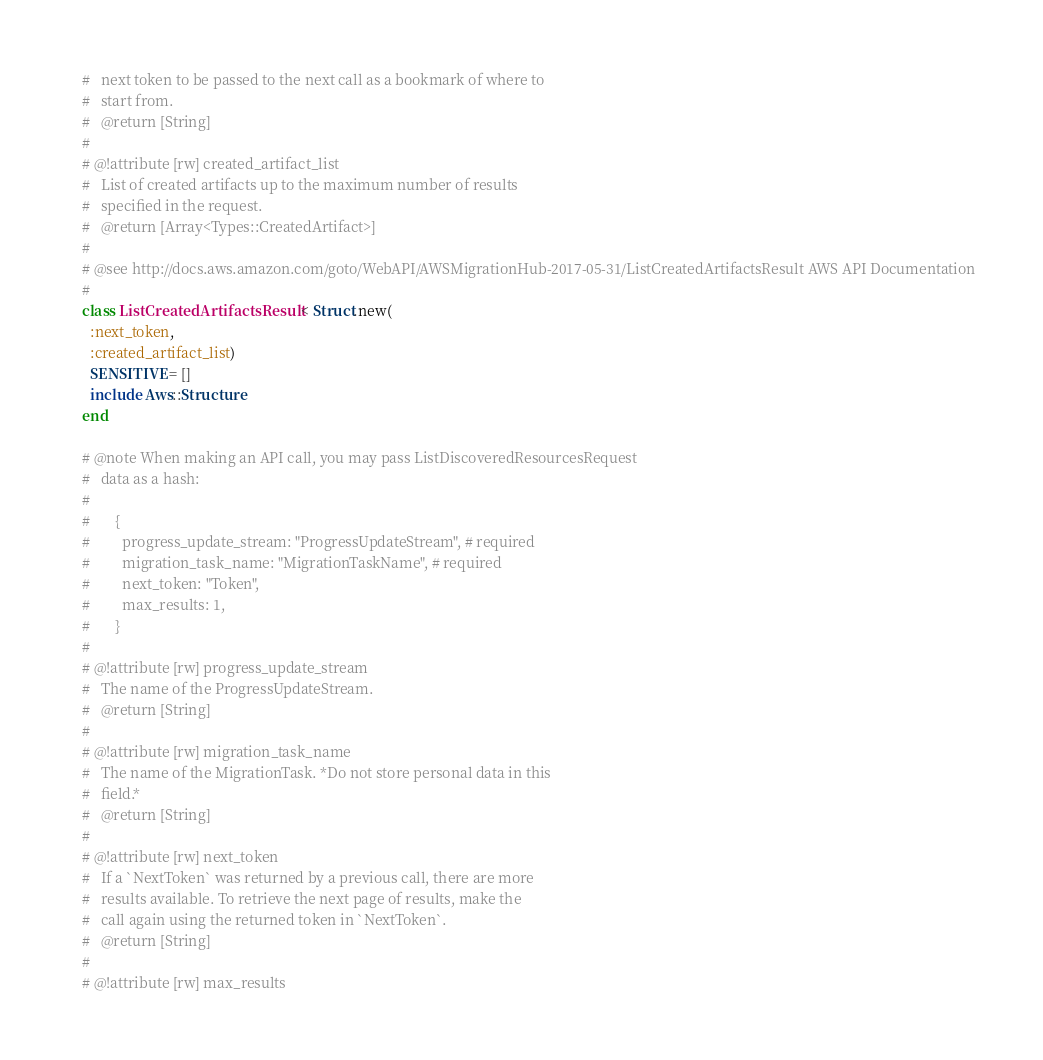Convert code to text. <code><loc_0><loc_0><loc_500><loc_500><_Ruby_>    #   next token to be passed to the next call as a bookmark of where to
    #   start from.
    #   @return [String]
    #
    # @!attribute [rw] created_artifact_list
    #   List of created artifacts up to the maximum number of results
    #   specified in the request.
    #   @return [Array<Types::CreatedArtifact>]
    #
    # @see http://docs.aws.amazon.com/goto/WebAPI/AWSMigrationHub-2017-05-31/ListCreatedArtifactsResult AWS API Documentation
    #
    class ListCreatedArtifactsResult < Struct.new(
      :next_token,
      :created_artifact_list)
      SENSITIVE = []
      include Aws::Structure
    end

    # @note When making an API call, you may pass ListDiscoveredResourcesRequest
    #   data as a hash:
    #
    #       {
    #         progress_update_stream: "ProgressUpdateStream", # required
    #         migration_task_name: "MigrationTaskName", # required
    #         next_token: "Token",
    #         max_results: 1,
    #       }
    #
    # @!attribute [rw] progress_update_stream
    #   The name of the ProgressUpdateStream.
    #   @return [String]
    #
    # @!attribute [rw] migration_task_name
    #   The name of the MigrationTask. *Do not store personal data in this
    #   field.*
    #   @return [String]
    #
    # @!attribute [rw] next_token
    #   If a `NextToken` was returned by a previous call, there are more
    #   results available. To retrieve the next page of results, make the
    #   call again using the returned token in `NextToken`.
    #   @return [String]
    #
    # @!attribute [rw] max_results</code> 